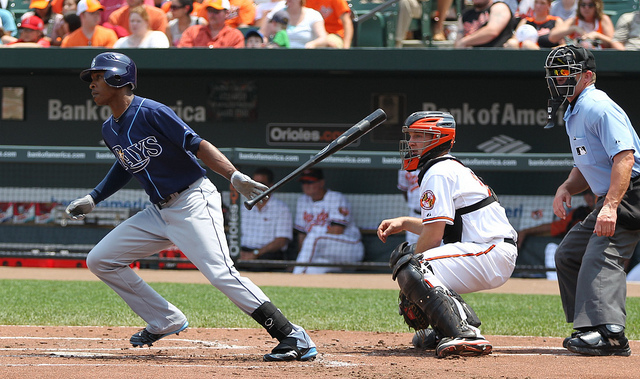Identify the text contained in this image. Bank Orioles of 